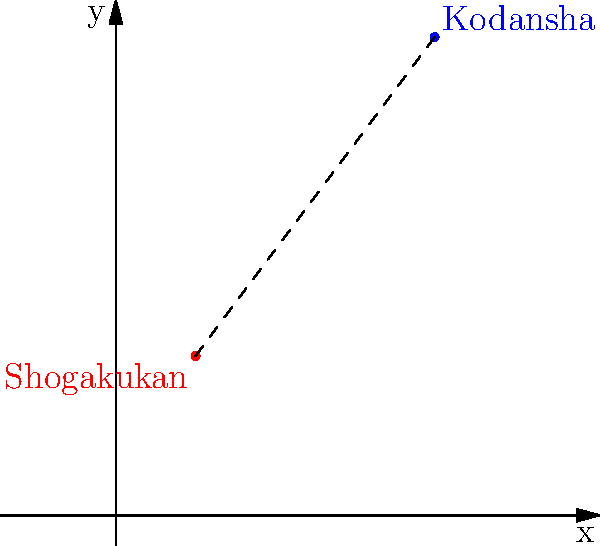In Tokyo's manga publishing district, Shogakukan's headquarters is located at coordinates (1, 2), while Kodansha's main office is at (4, 6) on a coordinate plane where each unit represents 100 meters. What is the shortest distance between these two major manga publishing houses? To find the shortest distance between two points on a coordinate plane, we can use the distance formula:

$$d = \sqrt{(x_2 - x_1)^2 + (y_2 - y_1)^2}$$

Where $(x_1, y_1)$ is the coordinate of the first point and $(x_2, y_2)$ is the coordinate of the second point.

Let's plug in the values:
Shogakukan: $(x_1, y_1) = (1, 2)$
Kodansha: $(x_2, y_2) = (4, 6)$

$$d = \sqrt{(4 - 1)^2 + (6 - 2)^2}$$

Simplify:
$$d = \sqrt{3^2 + 4^2}$$
$$d = \sqrt{9 + 16}$$
$$d = \sqrt{25}$$
$$d = 5$$

Since each unit represents 100 meters, we multiply the result by 100:

$5 \times 100 = 500$ meters

Therefore, the shortest distance between Shogakukan and Kodansha is 500 meters.
Answer: 500 meters 